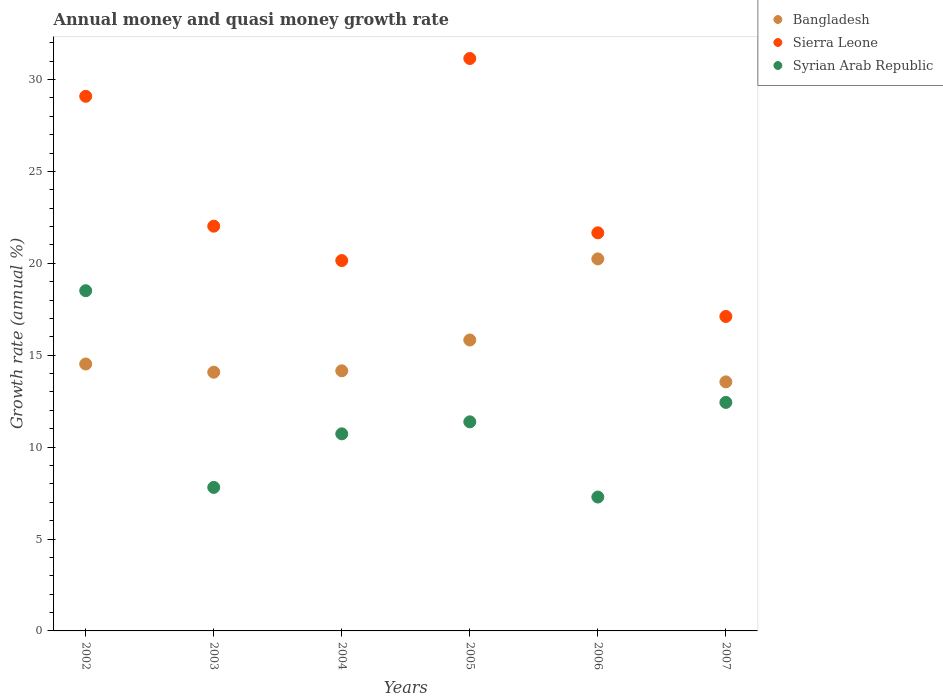What is the growth rate in Syrian Arab Republic in 2004?
Offer a terse response. 10.72. Across all years, what is the maximum growth rate in Sierra Leone?
Your answer should be very brief. 31.15. Across all years, what is the minimum growth rate in Sierra Leone?
Your answer should be very brief. 17.11. What is the total growth rate in Sierra Leone in the graph?
Your response must be concise. 141.18. What is the difference between the growth rate in Syrian Arab Republic in 2004 and that in 2007?
Keep it short and to the point. -1.71. What is the difference between the growth rate in Sierra Leone in 2004 and the growth rate in Syrian Arab Republic in 2005?
Keep it short and to the point. 8.78. What is the average growth rate in Bangladesh per year?
Your answer should be very brief. 15.4. In the year 2007, what is the difference between the growth rate in Bangladesh and growth rate in Syrian Arab Republic?
Ensure brevity in your answer.  1.12. What is the ratio of the growth rate in Syrian Arab Republic in 2004 to that in 2007?
Your response must be concise. 0.86. Is the growth rate in Syrian Arab Republic in 2003 less than that in 2004?
Your answer should be compact. Yes. What is the difference between the highest and the second highest growth rate in Syrian Arab Republic?
Make the answer very short. 6.08. What is the difference between the highest and the lowest growth rate in Syrian Arab Republic?
Provide a succinct answer. 11.23. Does the growth rate in Sierra Leone monotonically increase over the years?
Provide a succinct answer. No. Is the growth rate in Sierra Leone strictly greater than the growth rate in Syrian Arab Republic over the years?
Give a very brief answer. Yes. How many years are there in the graph?
Your answer should be very brief. 6. Are the values on the major ticks of Y-axis written in scientific E-notation?
Keep it short and to the point. No. Does the graph contain any zero values?
Provide a short and direct response. No. Does the graph contain grids?
Provide a succinct answer. No. Where does the legend appear in the graph?
Keep it short and to the point. Top right. How are the legend labels stacked?
Give a very brief answer. Vertical. What is the title of the graph?
Your response must be concise. Annual money and quasi money growth rate. Does "Other small states" appear as one of the legend labels in the graph?
Provide a succinct answer. No. What is the label or title of the Y-axis?
Provide a succinct answer. Growth rate (annual %). What is the Growth rate (annual %) in Bangladesh in 2002?
Ensure brevity in your answer.  14.52. What is the Growth rate (annual %) in Sierra Leone in 2002?
Offer a terse response. 29.09. What is the Growth rate (annual %) of Syrian Arab Republic in 2002?
Your answer should be compact. 18.51. What is the Growth rate (annual %) in Bangladesh in 2003?
Your response must be concise. 14.08. What is the Growth rate (annual %) in Sierra Leone in 2003?
Offer a terse response. 22.02. What is the Growth rate (annual %) in Syrian Arab Republic in 2003?
Ensure brevity in your answer.  7.81. What is the Growth rate (annual %) in Bangladesh in 2004?
Keep it short and to the point. 14.15. What is the Growth rate (annual %) in Sierra Leone in 2004?
Ensure brevity in your answer.  20.15. What is the Growth rate (annual %) of Syrian Arab Republic in 2004?
Your response must be concise. 10.72. What is the Growth rate (annual %) in Bangladesh in 2005?
Your response must be concise. 15.83. What is the Growth rate (annual %) of Sierra Leone in 2005?
Give a very brief answer. 31.15. What is the Growth rate (annual %) in Syrian Arab Republic in 2005?
Make the answer very short. 11.38. What is the Growth rate (annual %) in Bangladesh in 2006?
Ensure brevity in your answer.  20.24. What is the Growth rate (annual %) in Sierra Leone in 2006?
Provide a succinct answer. 21.66. What is the Growth rate (annual %) in Syrian Arab Republic in 2006?
Provide a succinct answer. 7.29. What is the Growth rate (annual %) of Bangladesh in 2007?
Provide a succinct answer. 13.55. What is the Growth rate (annual %) of Sierra Leone in 2007?
Ensure brevity in your answer.  17.11. What is the Growth rate (annual %) of Syrian Arab Republic in 2007?
Make the answer very short. 12.43. Across all years, what is the maximum Growth rate (annual %) in Bangladesh?
Ensure brevity in your answer.  20.24. Across all years, what is the maximum Growth rate (annual %) of Sierra Leone?
Keep it short and to the point. 31.15. Across all years, what is the maximum Growth rate (annual %) in Syrian Arab Republic?
Your answer should be compact. 18.51. Across all years, what is the minimum Growth rate (annual %) in Bangladesh?
Give a very brief answer. 13.55. Across all years, what is the minimum Growth rate (annual %) in Sierra Leone?
Ensure brevity in your answer.  17.11. Across all years, what is the minimum Growth rate (annual %) of Syrian Arab Republic?
Give a very brief answer. 7.29. What is the total Growth rate (annual %) of Bangladesh in the graph?
Your answer should be very brief. 92.37. What is the total Growth rate (annual %) of Sierra Leone in the graph?
Provide a short and direct response. 141.18. What is the total Growth rate (annual %) of Syrian Arab Republic in the graph?
Offer a very short reply. 68.14. What is the difference between the Growth rate (annual %) of Bangladesh in 2002 and that in 2003?
Give a very brief answer. 0.45. What is the difference between the Growth rate (annual %) of Sierra Leone in 2002 and that in 2003?
Provide a succinct answer. 7.07. What is the difference between the Growth rate (annual %) in Syrian Arab Republic in 2002 and that in 2003?
Your answer should be compact. 10.7. What is the difference between the Growth rate (annual %) in Bangladesh in 2002 and that in 2004?
Make the answer very short. 0.37. What is the difference between the Growth rate (annual %) in Sierra Leone in 2002 and that in 2004?
Your answer should be very brief. 8.94. What is the difference between the Growth rate (annual %) of Syrian Arab Republic in 2002 and that in 2004?
Your answer should be compact. 7.79. What is the difference between the Growth rate (annual %) in Bangladesh in 2002 and that in 2005?
Your answer should be compact. -1.31. What is the difference between the Growth rate (annual %) of Sierra Leone in 2002 and that in 2005?
Keep it short and to the point. -2.06. What is the difference between the Growth rate (annual %) of Syrian Arab Republic in 2002 and that in 2005?
Ensure brevity in your answer.  7.13. What is the difference between the Growth rate (annual %) of Bangladesh in 2002 and that in 2006?
Ensure brevity in your answer.  -5.72. What is the difference between the Growth rate (annual %) of Sierra Leone in 2002 and that in 2006?
Ensure brevity in your answer.  7.43. What is the difference between the Growth rate (annual %) in Syrian Arab Republic in 2002 and that in 2006?
Offer a very short reply. 11.23. What is the difference between the Growth rate (annual %) in Bangladesh in 2002 and that in 2007?
Offer a very short reply. 0.97. What is the difference between the Growth rate (annual %) in Sierra Leone in 2002 and that in 2007?
Your response must be concise. 11.98. What is the difference between the Growth rate (annual %) of Syrian Arab Republic in 2002 and that in 2007?
Make the answer very short. 6.08. What is the difference between the Growth rate (annual %) in Bangladesh in 2003 and that in 2004?
Offer a terse response. -0.08. What is the difference between the Growth rate (annual %) of Sierra Leone in 2003 and that in 2004?
Your answer should be very brief. 1.87. What is the difference between the Growth rate (annual %) in Syrian Arab Republic in 2003 and that in 2004?
Offer a terse response. -2.91. What is the difference between the Growth rate (annual %) in Bangladesh in 2003 and that in 2005?
Offer a terse response. -1.75. What is the difference between the Growth rate (annual %) in Sierra Leone in 2003 and that in 2005?
Offer a very short reply. -9.12. What is the difference between the Growth rate (annual %) in Syrian Arab Republic in 2003 and that in 2005?
Offer a terse response. -3.57. What is the difference between the Growth rate (annual %) in Bangladesh in 2003 and that in 2006?
Keep it short and to the point. -6.16. What is the difference between the Growth rate (annual %) in Sierra Leone in 2003 and that in 2006?
Keep it short and to the point. 0.36. What is the difference between the Growth rate (annual %) in Syrian Arab Republic in 2003 and that in 2006?
Ensure brevity in your answer.  0.52. What is the difference between the Growth rate (annual %) in Bangladesh in 2003 and that in 2007?
Give a very brief answer. 0.53. What is the difference between the Growth rate (annual %) of Sierra Leone in 2003 and that in 2007?
Offer a terse response. 4.91. What is the difference between the Growth rate (annual %) of Syrian Arab Republic in 2003 and that in 2007?
Provide a succinct answer. -4.62. What is the difference between the Growth rate (annual %) of Bangladesh in 2004 and that in 2005?
Ensure brevity in your answer.  -1.68. What is the difference between the Growth rate (annual %) in Sierra Leone in 2004 and that in 2005?
Your response must be concise. -10.99. What is the difference between the Growth rate (annual %) in Syrian Arab Republic in 2004 and that in 2005?
Your answer should be compact. -0.65. What is the difference between the Growth rate (annual %) of Bangladesh in 2004 and that in 2006?
Your response must be concise. -6.09. What is the difference between the Growth rate (annual %) in Sierra Leone in 2004 and that in 2006?
Your response must be concise. -1.51. What is the difference between the Growth rate (annual %) in Syrian Arab Republic in 2004 and that in 2006?
Provide a short and direct response. 3.44. What is the difference between the Growth rate (annual %) of Bangladesh in 2004 and that in 2007?
Offer a terse response. 0.6. What is the difference between the Growth rate (annual %) of Sierra Leone in 2004 and that in 2007?
Your answer should be compact. 3.04. What is the difference between the Growth rate (annual %) in Syrian Arab Republic in 2004 and that in 2007?
Make the answer very short. -1.71. What is the difference between the Growth rate (annual %) of Bangladesh in 2005 and that in 2006?
Your response must be concise. -4.41. What is the difference between the Growth rate (annual %) of Sierra Leone in 2005 and that in 2006?
Offer a terse response. 9.48. What is the difference between the Growth rate (annual %) in Syrian Arab Republic in 2005 and that in 2006?
Your answer should be compact. 4.09. What is the difference between the Growth rate (annual %) of Bangladesh in 2005 and that in 2007?
Provide a short and direct response. 2.28. What is the difference between the Growth rate (annual %) in Sierra Leone in 2005 and that in 2007?
Your answer should be compact. 14.04. What is the difference between the Growth rate (annual %) of Syrian Arab Republic in 2005 and that in 2007?
Offer a very short reply. -1.06. What is the difference between the Growth rate (annual %) in Bangladesh in 2006 and that in 2007?
Your answer should be very brief. 6.69. What is the difference between the Growth rate (annual %) of Sierra Leone in 2006 and that in 2007?
Offer a terse response. 4.55. What is the difference between the Growth rate (annual %) of Syrian Arab Republic in 2006 and that in 2007?
Give a very brief answer. -5.15. What is the difference between the Growth rate (annual %) in Bangladesh in 2002 and the Growth rate (annual %) in Sierra Leone in 2003?
Your answer should be compact. -7.5. What is the difference between the Growth rate (annual %) of Bangladesh in 2002 and the Growth rate (annual %) of Syrian Arab Republic in 2003?
Your answer should be very brief. 6.71. What is the difference between the Growth rate (annual %) of Sierra Leone in 2002 and the Growth rate (annual %) of Syrian Arab Republic in 2003?
Your answer should be very brief. 21.28. What is the difference between the Growth rate (annual %) of Bangladesh in 2002 and the Growth rate (annual %) of Sierra Leone in 2004?
Your response must be concise. -5.63. What is the difference between the Growth rate (annual %) of Bangladesh in 2002 and the Growth rate (annual %) of Syrian Arab Republic in 2004?
Give a very brief answer. 3.8. What is the difference between the Growth rate (annual %) in Sierra Leone in 2002 and the Growth rate (annual %) in Syrian Arab Republic in 2004?
Keep it short and to the point. 18.37. What is the difference between the Growth rate (annual %) in Bangladesh in 2002 and the Growth rate (annual %) in Sierra Leone in 2005?
Give a very brief answer. -16.62. What is the difference between the Growth rate (annual %) of Bangladesh in 2002 and the Growth rate (annual %) of Syrian Arab Republic in 2005?
Keep it short and to the point. 3.15. What is the difference between the Growth rate (annual %) of Sierra Leone in 2002 and the Growth rate (annual %) of Syrian Arab Republic in 2005?
Your response must be concise. 17.71. What is the difference between the Growth rate (annual %) in Bangladesh in 2002 and the Growth rate (annual %) in Sierra Leone in 2006?
Your answer should be compact. -7.14. What is the difference between the Growth rate (annual %) of Bangladesh in 2002 and the Growth rate (annual %) of Syrian Arab Republic in 2006?
Your answer should be very brief. 7.24. What is the difference between the Growth rate (annual %) in Sierra Leone in 2002 and the Growth rate (annual %) in Syrian Arab Republic in 2006?
Provide a short and direct response. 21.8. What is the difference between the Growth rate (annual %) in Bangladesh in 2002 and the Growth rate (annual %) in Sierra Leone in 2007?
Offer a terse response. -2.59. What is the difference between the Growth rate (annual %) of Bangladesh in 2002 and the Growth rate (annual %) of Syrian Arab Republic in 2007?
Give a very brief answer. 2.09. What is the difference between the Growth rate (annual %) of Sierra Leone in 2002 and the Growth rate (annual %) of Syrian Arab Republic in 2007?
Offer a terse response. 16.66. What is the difference between the Growth rate (annual %) in Bangladesh in 2003 and the Growth rate (annual %) in Sierra Leone in 2004?
Your response must be concise. -6.07. What is the difference between the Growth rate (annual %) in Bangladesh in 2003 and the Growth rate (annual %) in Syrian Arab Republic in 2004?
Offer a very short reply. 3.35. What is the difference between the Growth rate (annual %) of Sierra Leone in 2003 and the Growth rate (annual %) of Syrian Arab Republic in 2004?
Your answer should be very brief. 11.3. What is the difference between the Growth rate (annual %) of Bangladesh in 2003 and the Growth rate (annual %) of Sierra Leone in 2005?
Your response must be concise. -17.07. What is the difference between the Growth rate (annual %) in Bangladesh in 2003 and the Growth rate (annual %) in Syrian Arab Republic in 2005?
Keep it short and to the point. 2.7. What is the difference between the Growth rate (annual %) of Sierra Leone in 2003 and the Growth rate (annual %) of Syrian Arab Republic in 2005?
Offer a terse response. 10.65. What is the difference between the Growth rate (annual %) in Bangladesh in 2003 and the Growth rate (annual %) in Sierra Leone in 2006?
Give a very brief answer. -7.58. What is the difference between the Growth rate (annual %) in Bangladesh in 2003 and the Growth rate (annual %) in Syrian Arab Republic in 2006?
Give a very brief answer. 6.79. What is the difference between the Growth rate (annual %) of Sierra Leone in 2003 and the Growth rate (annual %) of Syrian Arab Republic in 2006?
Make the answer very short. 14.74. What is the difference between the Growth rate (annual %) of Bangladesh in 2003 and the Growth rate (annual %) of Sierra Leone in 2007?
Make the answer very short. -3.03. What is the difference between the Growth rate (annual %) of Bangladesh in 2003 and the Growth rate (annual %) of Syrian Arab Republic in 2007?
Offer a very short reply. 1.64. What is the difference between the Growth rate (annual %) in Sierra Leone in 2003 and the Growth rate (annual %) in Syrian Arab Republic in 2007?
Your answer should be compact. 9.59. What is the difference between the Growth rate (annual %) of Bangladesh in 2004 and the Growth rate (annual %) of Sierra Leone in 2005?
Your response must be concise. -16.99. What is the difference between the Growth rate (annual %) in Bangladesh in 2004 and the Growth rate (annual %) in Syrian Arab Republic in 2005?
Make the answer very short. 2.78. What is the difference between the Growth rate (annual %) in Sierra Leone in 2004 and the Growth rate (annual %) in Syrian Arab Republic in 2005?
Ensure brevity in your answer.  8.78. What is the difference between the Growth rate (annual %) of Bangladesh in 2004 and the Growth rate (annual %) of Sierra Leone in 2006?
Make the answer very short. -7.51. What is the difference between the Growth rate (annual %) in Bangladesh in 2004 and the Growth rate (annual %) in Syrian Arab Republic in 2006?
Your answer should be very brief. 6.87. What is the difference between the Growth rate (annual %) of Sierra Leone in 2004 and the Growth rate (annual %) of Syrian Arab Republic in 2006?
Offer a terse response. 12.87. What is the difference between the Growth rate (annual %) in Bangladesh in 2004 and the Growth rate (annual %) in Sierra Leone in 2007?
Make the answer very short. -2.96. What is the difference between the Growth rate (annual %) in Bangladesh in 2004 and the Growth rate (annual %) in Syrian Arab Republic in 2007?
Offer a terse response. 1.72. What is the difference between the Growth rate (annual %) in Sierra Leone in 2004 and the Growth rate (annual %) in Syrian Arab Republic in 2007?
Give a very brief answer. 7.72. What is the difference between the Growth rate (annual %) in Bangladesh in 2005 and the Growth rate (annual %) in Sierra Leone in 2006?
Ensure brevity in your answer.  -5.83. What is the difference between the Growth rate (annual %) of Bangladesh in 2005 and the Growth rate (annual %) of Syrian Arab Republic in 2006?
Offer a terse response. 8.54. What is the difference between the Growth rate (annual %) of Sierra Leone in 2005 and the Growth rate (annual %) of Syrian Arab Republic in 2006?
Give a very brief answer. 23.86. What is the difference between the Growth rate (annual %) of Bangladesh in 2005 and the Growth rate (annual %) of Sierra Leone in 2007?
Ensure brevity in your answer.  -1.28. What is the difference between the Growth rate (annual %) in Bangladesh in 2005 and the Growth rate (annual %) in Syrian Arab Republic in 2007?
Ensure brevity in your answer.  3.4. What is the difference between the Growth rate (annual %) of Sierra Leone in 2005 and the Growth rate (annual %) of Syrian Arab Republic in 2007?
Your response must be concise. 18.71. What is the difference between the Growth rate (annual %) in Bangladesh in 2006 and the Growth rate (annual %) in Sierra Leone in 2007?
Make the answer very short. 3.13. What is the difference between the Growth rate (annual %) of Bangladesh in 2006 and the Growth rate (annual %) of Syrian Arab Republic in 2007?
Keep it short and to the point. 7.81. What is the difference between the Growth rate (annual %) of Sierra Leone in 2006 and the Growth rate (annual %) of Syrian Arab Republic in 2007?
Offer a very short reply. 9.23. What is the average Growth rate (annual %) of Bangladesh per year?
Your answer should be compact. 15.4. What is the average Growth rate (annual %) in Sierra Leone per year?
Provide a short and direct response. 23.53. What is the average Growth rate (annual %) in Syrian Arab Republic per year?
Provide a short and direct response. 11.36. In the year 2002, what is the difference between the Growth rate (annual %) in Bangladesh and Growth rate (annual %) in Sierra Leone?
Make the answer very short. -14.57. In the year 2002, what is the difference between the Growth rate (annual %) of Bangladesh and Growth rate (annual %) of Syrian Arab Republic?
Make the answer very short. -3.99. In the year 2002, what is the difference between the Growth rate (annual %) of Sierra Leone and Growth rate (annual %) of Syrian Arab Republic?
Make the answer very short. 10.58. In the year 2003, what is the difference between the Growth rate (annual %) of Bangladesh and Growth rate (annual %) of Sierra Leone?
Keep it short and to the point. -7.95. In the year 2003, what is the difference between the Growth rate (annual %) in Bangladesh and Growth rate (annual %) in Syrian Arab Republic?
Make the answer very short. 6.27. In the year 2003, what is the difference between the Growth rate (annual %) in Sierra Leone and Growth rate (annual %) in Syrian Arab Republic?
Provide a succinct answer. 14.21. In the year 2004, what is the difference between the Growth rate (annual %) in Bangladesh and Growth rate (annual %) in Sierra Leone?
Give a very brief answer. -6. In the year 2004, what is the difference between the Growth rate (annual %) of Bangladesh and Growth rate (annual %) of Syrian Arab Republic?
Give a very brief answer. 3.43. In the year 2004, what is the difference between the Growth rate (annual %) of Sierra Leone and Growth rate (annual %) of Syrian Arab Republic?
Your response must be concise. 9.43. In the year 2005, what is the difference between the Growth rate (annual %) of Bangladesh and Growth rate (annual %) of Sierra Leone?
Give a very brief answer. -15.32. In the year 2005, what is the difference between the Growth rate (annual %) of Bangladesh and Growth rate (annual %) of Syrian Arab Republic?
Your answer should be compact. 4.45. In the year 2005, what is the difference between the Growth rate (annual %) in Sierra Leone and Growth rate (annual %) in Syrian Arab Republic?
Ensure brevity in your answer.  19.77. In the year 2006, what is the difference between the Growth rate (annual %) in Bangladesh and Growth rate (annual %) in Sierra Leone?
Your answer should be compact. -1.42. In the year 2006, what is the difference between the Growth rate (annual %) of Bangladesh and Growth rate (annual %) of Syrian Arab Republic?
Make the answer very short. 12.96. In the year 2006, what is the difference between the Growth rate (annual %) in Sierra Leone and Growth rate (annual %) in Syrian Arab Republic?
Ensure brevity in your answer.  14.38. In the year 2007, what is the difference between the Growth rate (annual %) of Bangladesh and Growth rate (annual %) of Sierra Leone?
Keep it short and to the point. -3.56. In the year 2007, what is the difference between the Growth rate (annual %) of Bangladesh and Growth rate (annual %) of Syrian Arab Republic?
Give a very brief answer. 1.12. In the year 2007, what is the difference between the Growth rate (annual %) of Sierra Leone and Growth rate (annual %) of Syrian Arab Republic?
Your answer should be compact. 4.68. What is the ratio of the Growth rate (annual %) in Bangladesh in 2002 to that in 2003?
Keep it short and to the point. 1.03. What is the ratio of the Growth rate (annual %) in Sierra Leone in 2002 to that in 2003?
Provide a succinct answer. 1.32. What is the ratio of the Growth rate (annual %) of Syrian Arab Republic in 2002 to that in 2003?
Offer a terse response. 2.37. What is the ratio of the Growth rate (annual %) in Bangladesh in 2002 to that in 2004?
Keep it short and to the point. 1.03. What is the ratio of the Growth rate (annual %) of Sierra Leone in 2002 to that in 2004?
Provide a short and direct response. 1.44. What is the ratio of the Growth rate (annual %) in Syrian Arab Republic in 2002 to that in 2004?
Your response must be concise. 1.73. What is the ratio of the Growth rate (annual %) in Bangladesh in 2002 to that in 2005?
Provide a succinct answer. 0.92. What is the ratio of the Growth rate (annual %) in Sierra Leone in 2002 to that in 2005?
Your response must be concise. 0.93. What is the ratio of the Growth rate (annual %) of Syrian Arab Republic in 2002 to that in 2005?
Provide a short and direct response. 1.63. What is the ratio of the Growth rate (annual %) of Bangladesh in 2002 to that in 2006?
Keep it short and to the point. 0.72. What is the ratio of the Growth rate (annual %) in Sierra Leone in 2002 to that in 2006?
Give a very brief answer. 1.34. What is the ratio of the Growth rate (annual %) in Syrian Arab Republic in 2002 to that in 2006?
Provide a short and direct response. 2.54. What is the ratio of the Growth rate (annual %) of Bangladesh in 2002 to that in 2007?
Your response must be concise. 1.07. What is the ratio of the Growth rate (annual %) in Sierra Leone in 2002 to that in 2007?
Give a very brief answer. 1.7. What is the ratio of the Growth rate (annual %) of Syrian Arab Republic in 2002 to that in 2007?
Offer a very short reply. 1.49. What is the ratio of the Growth rate (annual %) in Sierra Leone in 2003 to that in 2004?
Provide a succinct answer. 1.09. What is the ratio of the Growth rate (annual %) of Syrian Arab Republic in 2003 to that in 2004?
Your answer should be compact. 0.73. What is the ratio of the Growth rate (annual %) in Bangladesh in 2003 to that in 2005?
Your answer should be very brief. 0.89. What is the ratio of the Growth rate (annual %) of Sierra Leone in 2003 to that in 2005?
Provide a short and direct response. 0.71. What is the ratio of the Growth rate (annual %) in Syrian Arab Republic in 2003 to that in 2005?
Ensure brevity in your answer.  0.69. What is the ratio of the Growth rate (annual %) in Bangladesh in 2003 to that in 2006?
Make the answer very short. 0.7. What is the ratio of the Growth rate (annual %) in Sierra Leone in 2003 to that in 2006?
Give a very brief answer. 1.02. What is the ratio of the Growth rate (annual %) of Syrian Arab Republic in 2003 to that in 2006?
Give a very brief answer. 1.07. What is the ratio of the Growth rate (annual %) of Bangladesh in 2003 to that in 2007?
Ensure brevity in your answer.  1.04. What is the ratio of the Growth rate (annual %) in Sierra Leone in 2003 to that in 2007?
Provide a short and direct response. 1.29. What is the ratio of the Growth rate (annual %) of Syrian Arab Republic in 2003 to that in 2007?
Your answer should be compact. 0.63. What is the ratio of the Growth rate (annual %) in Bangladesh in 2004 to that in 2005?
Make the answer very short. 0.89. What is the ratio of the Growth rate (annual %) in Sierra Leone in 2004 to that in 2005?
Make the answer very short. 0.65. What is the ratio of the Growth rate (annual %) in Syrian Arab Republic in 2004 to that in 2005?
Make the answer very short. 0.94. What is the ratio of the Growth rate (annual %) of Bangladesh in 2004 to that in 2006?
Offer a very short reply. 0.7. What is the ratio of the Growth rate (annual %) of Sierra Leone in 2004 to that in 2006?
Keep it short and to the point. 0.93. What is the ratio of the Growth rate (annual %) of Syrian Arab Republic in 2004 to that in 2006?
Your answer should be compact. 1.47. What is the ratio of the Growth rate (annual %) in Bangladesh in 2004 to that in 2007?
Provide a succinct answer. 1.04. What is the ratio of the Growth rate (annual %) in Sierra Leone in 2004 to that in 2007?
Ensure brevity in your answer.  1.18. What is the ratio of the Growth rate (annual %) in Syrian Arab Republic in 2004 to that in 2007?
Your answer should be compact. 0.86. What is the ratio of the Growth rate (annual %) of Bangladesh in 2005 to that in 2006?
Keep it short and to the point. 0.78. What is the ratio of the Growth rate (annual %) in Sierra Leone in 2005 to that in 2006?
Your answer should be compact. 1.44. What is the ratio of the Growth rate (annual %) in Syrian Arab Republic in 2005 to that in 2006?
Offer a very short reply. 1.56. What is the ratio of the Growth rate (annual %) in Bangladesh in 2005 to that in 2007?
Keep it short and to the point. 1.17. What is the ratio of the Growth rate (annual %) in Sierra Leone in 2005 to that in 2007?
Your answer should be compact. 1.82. What is the ratio of the Growth rate (annual %) in Syrian Arab Republic in 2005 to that in 2007?
Your answer should be very brief. 0.92. What is the ratio of the Growth rate (annual %) of Bangladesh in 2006 to that in 2007?
Provide a short and direct response. 1.49. What is the ratio of the Growth rate (annual %) in Sierra Leone in 2006 to that in 2007?
Make the answer very short. 1.27. What is the ratio of the Growth rate (annual %) of Syrian Arab Republic in 2006 to that in 2007?
Your answer should be compact. 0.59. What is the difference between the highest and the second highest Growth rate (annual %) of Bangladesh?
Your answer should be compact. 4.41. What is the difference between the highest and the second highest Growth rate (annual %) in Sierra Leone?
Give a very brief answer. 2.06. What is the difference between the highest and the second highest Growth rate (annual %) of Syrian Arab Republic?
Offer a very short reply. 6.08. What is the difference between the highest and the lowest Growth rate (annual %) of Bangladesh?
Offer a terse response. 6.69. What is the difference between the highest and the lowest Growth rate (annual %) in Sierra Leone?
Provide a succinct answer. 14.04. What is the difference between the highest and the lowest Growth rate (annual %) in Syrian Arab Republic?
Provide a succinct answer. 11.23. 